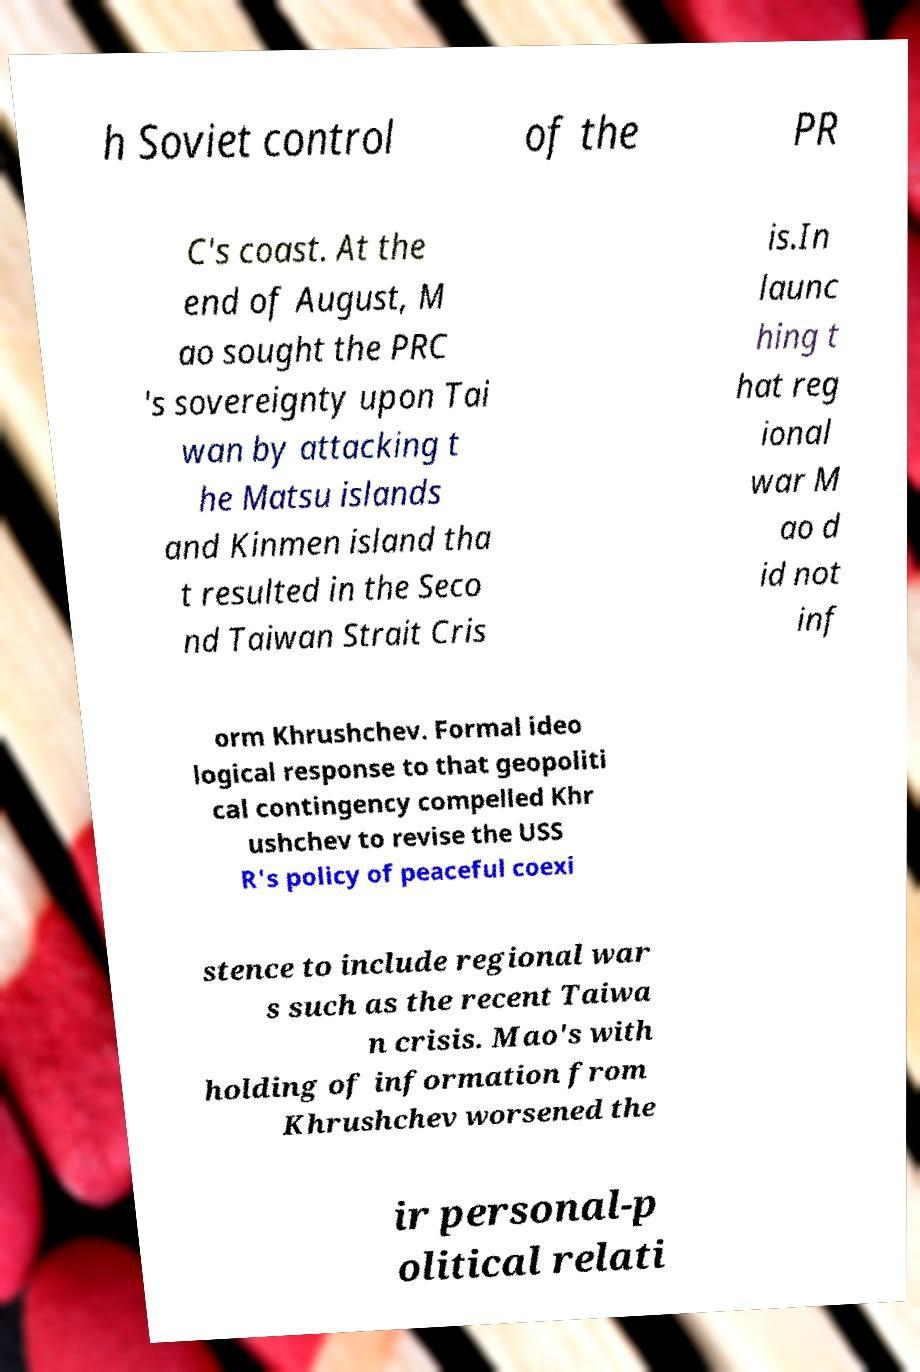Can you accurately transcribe the text from the provided image for me? h Soviet control of the PR C's coast. At the end of August, M ao sought the PRC 's sovereignty upon Tai wan by attacking t he Matsu islands and Kinmen island tha t resulted in the Seco nd Taiwan Strait Cris is.In launc hing t hat reg ional war M ao d id not inf orm Khrushchev. Formal ideo logical response to that geopoliti cal contingency compelled Khr ushchev to revise the USS R's policy of peaceful coexi stence to include regional war s such as the recent Taiwa n crisis. Mao's with holding of information from Khrushchev worsened the ir personal-p olitical relati 